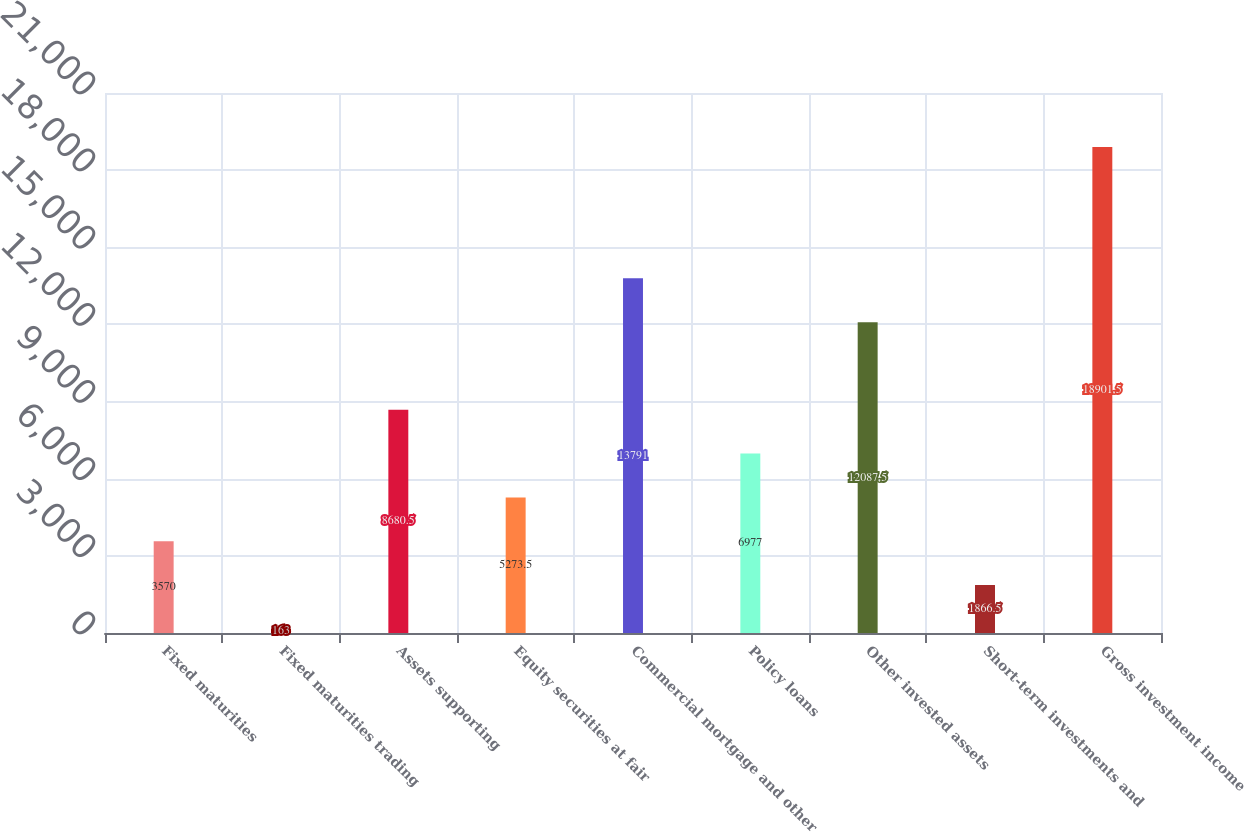<chart> <loc_0><loc_0><loc_500><loc_500><bar_chart><fcel>Fixed maturities<fcel>Fixed maturities trading<fcel>Assets supporting<fcel>Equity securities at fair<fcel>Commercial mortgage and other<fcel>Policy loans<fcel>Other invested assets<fcel>Short-term investments and<fcel>Gross investment income<nl><fcel>3570<fcel>163<fcel>8680.5<fcel>5273.5<fcel>13791<fcel>6977<fcel>12087.5<fcel>1866.5<fcel>18901.5<nl></chart> 